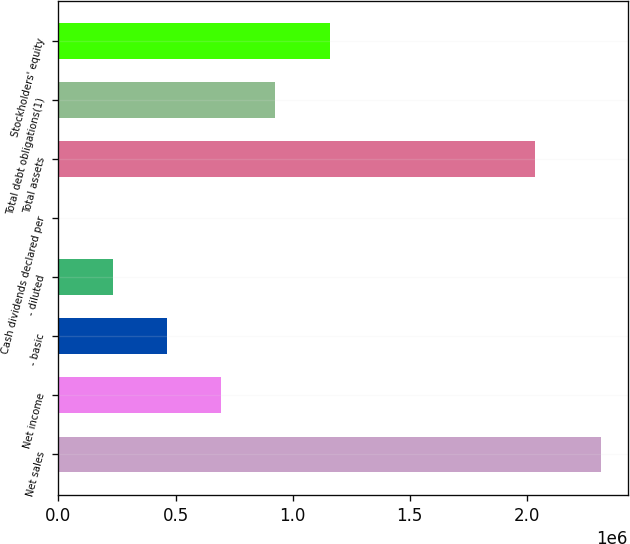Convert chart. <chart><loc_0><loc_0><loc_500><loc_500><bar_chart><fcel>Net sales<fcel>Net income<fcel>- basic<fcel>- diluted<fcel>Cash dividends declared per<fcel>Total assets<fcel>Total debt obligations(1)<fcel>Stockholders' equity<nl><fcel>2.31601e+06<fcel>694803<fcel>463202<fcel>231602<fcel>1.05<fcel>2.03586e+06<fcel>926403<fcel>1.158e+06<nl></chart> 